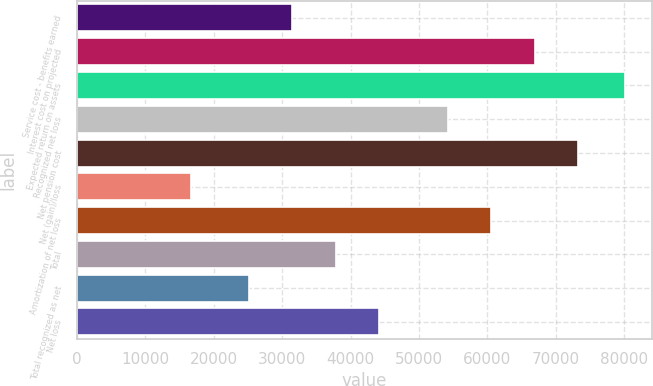<chart> <loc_0><loc_0><loc_500><loc_500><bar_chart><fcel>Service cost - benefits earned<fcel>Interest cost on projected<fcel>Expected return on assets<fcel>Recognized net loss<fcel>Net pension cost<fcel>Net (gain)/loss<fcel>Amortization of net loss<fcel>Total<fcel>Total recognized as net<fcel>Net loss<nl><fcel>31457.5<fcel>66937<fcel>80102<fcel>54254<fcel>73278.5<fcel>16687<fcel>60595.5<fcel>37799<fcel>25116<fcel>44140.5<nl></chart> 